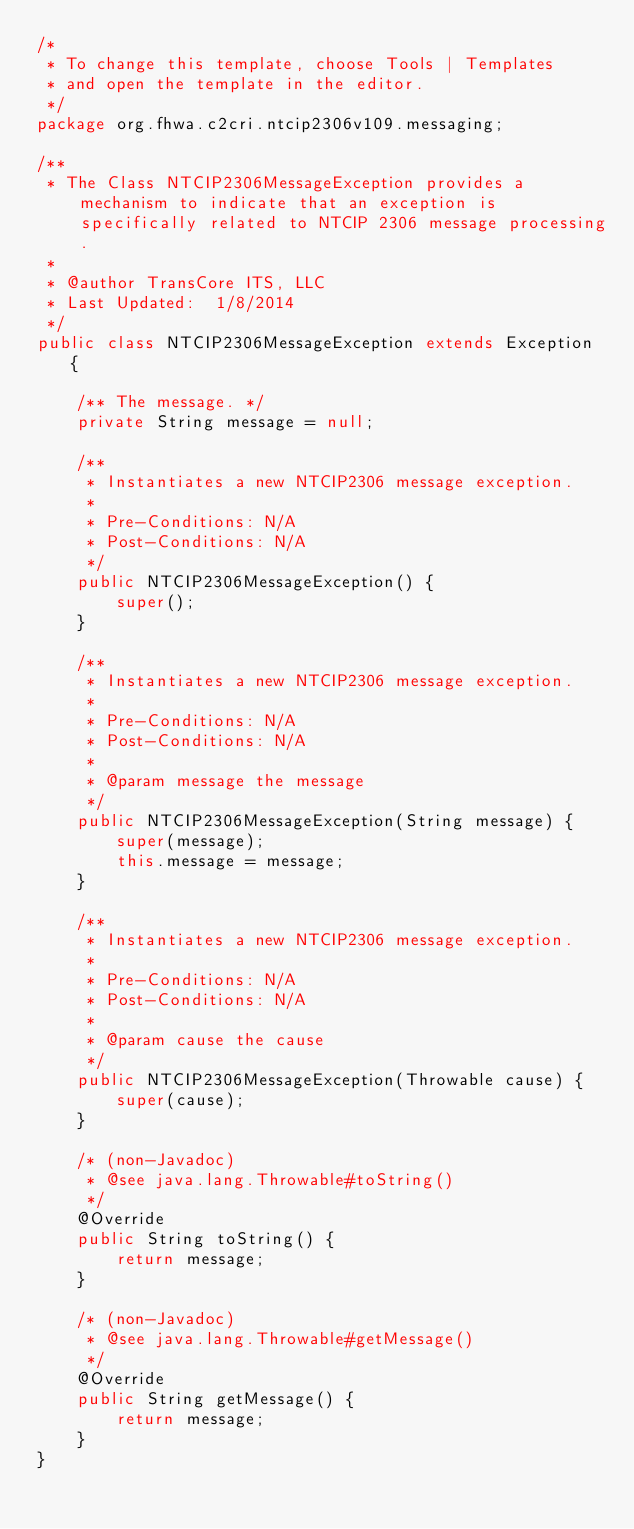<code> <loc_0><loc_0><loc_500><loc_500><_Java_>/*
 * To change this template, choose Tools | Templates
 * and open the template in the editor.
 */
package org.fhwa.c2cri.ntcip2306v109.messaging;

/**
 * The Class NTCIP2306MessageException provides a mechanism to indicate that an exception is specifically related to NTCIP 2306 message processing.
 *
 * @author TransCore ITS, LLC
 * Last Updated:  1/8/2014
 */
public class NTCIP2306MessageException extends Exception {

    /** The message. */
    private String message = null;

    /**
     * Instantiates a new NTCIP2306 message exception.
     * 
     * Pre-Conditions: N/A
     * Post-Conditions: N/A
     */
    public NTCIP2306MessageException() {
        super();
    }

    /**
     * Instantiates a new NTCIP2306 message exception.
     * 
     * Pre-Conditions: N/A
     * Post-Conditions: N/A
     *
     * @param message the message
     */
    public NTCIP2306MessageException(String message) {
        super(message);
        this.message = message;
    }

    /**
     * Instantiates a new NTCIP2306 message exception.
     * 
     * Pre-Conditions: N/A
     * Post-Conditions: N/A
     *
     * @param cause the cause
     */
    public NTCIP2306MessageException(Throwable cause) {
        super(cause);
    }

    /* (non-Javadoc)
     * @see java.lang.Throwable#toString()
     */
    @Override
    public String toString() {
        return message;
    }

    /* (non-Javadoc)
     * @see java.lang.Throwable#getMessage()
     */
    @Override
    public String getMessage() {
        return message;
    }
}
</code> 